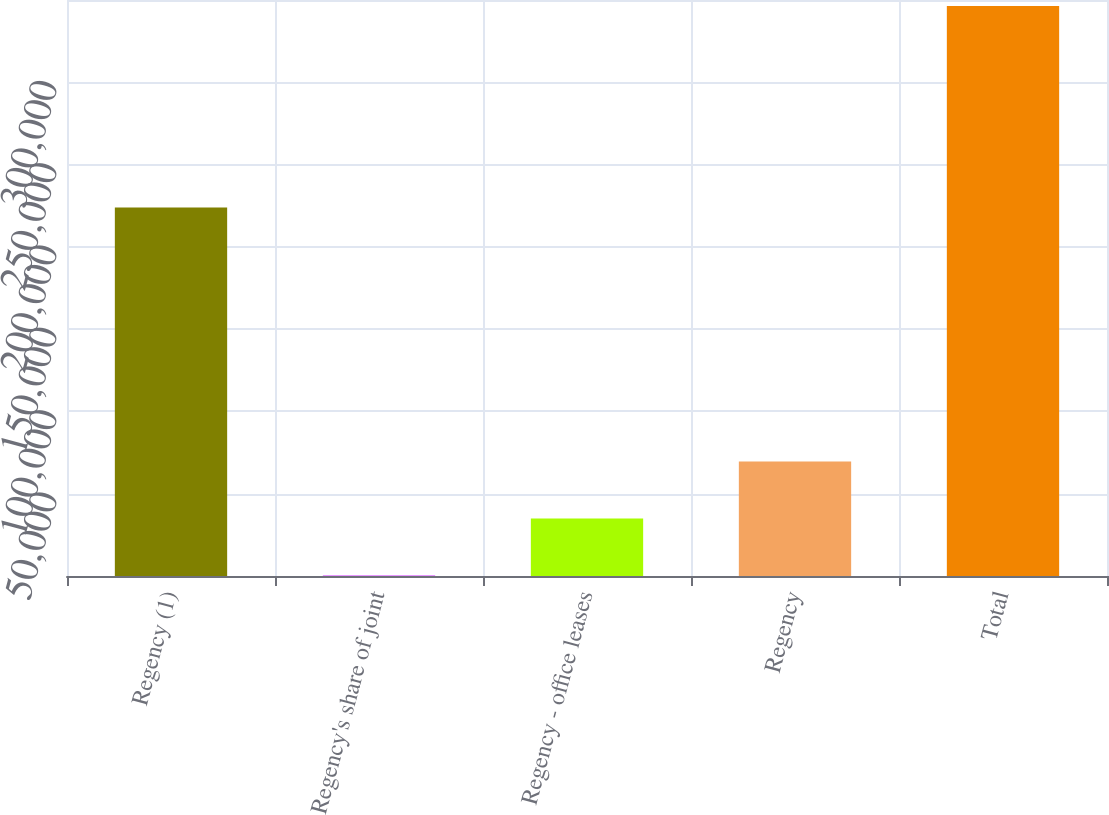Convert chart. <chart><loc_0><loc_0><loc_500><loc_500><bar_chart><fcel>Regency (1)<fcel>Regency's share of joint<fcel>Regency - office leases<fcel>Regency<fcel>Total<nl><fcel>223934<fcel>391<fcel>34994.1<fcel>69597.2<fcel>346422<nl></chart> 